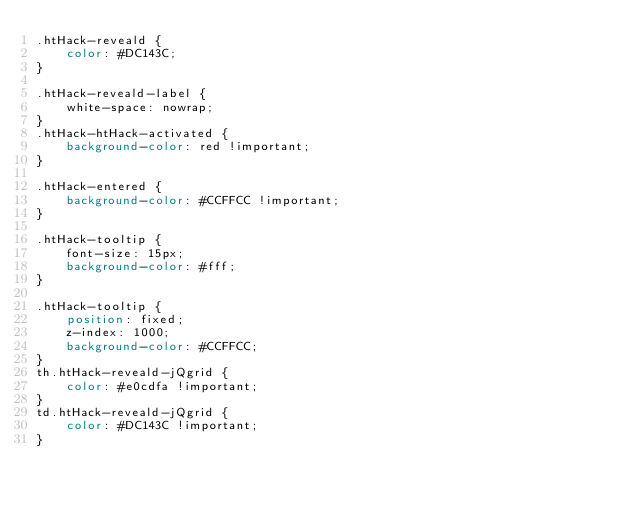Convert code to text. <code><loc_0><loc_0><loc_500><loc_500><_CSS_>.htHack-reveald {
    color: #DC143C;
}

.htHack-reveald-label {
	white-space: nowrap;
}
.htHack-htHack-activated {
    background-color: red !important;
}

.htHack-entered {
    background-color: #CCFFCC !important;
}

.htHack-tooltip {
    font-size: 15px;
    background-color: #fff;
}

.htHack-tooltip {
    position: fixed;
    z-index: 1000;
    background-color: #CCFFCC;
}
th.htHack-reveald-jQgrid {
    color: #e0cdfa !important;
}
td.htHack-reveald-jQgrid {
    color: #DC143C !important;
}</code> 